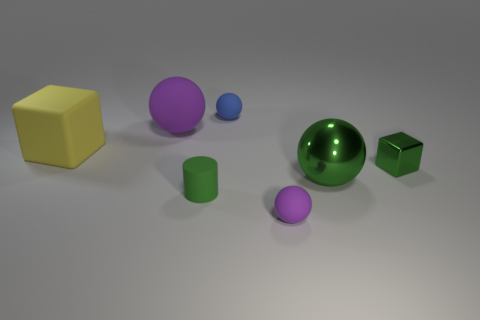Subtract all purple cylinders. How many purple spheres are left? 2 Subtract all green metal spheres. How many spheres are left? 3 Subtract all red balls. Subtract all yellow blocks. How many balls are left? 4 Add 3 small brown matte blocks. How many objects exist? 10 Subtract all spheres. How many objects are left? 3 Add 7 small purple rubber balls. How many small purple rubber balls are left? 8 Add 7 green cylinders. How many green cylinders exist? 8 Subtract 0 brown balls. How many objects are left? 7 Subtract all metallic balls. Subtract all shiny blocks. How many objects are left? 5 